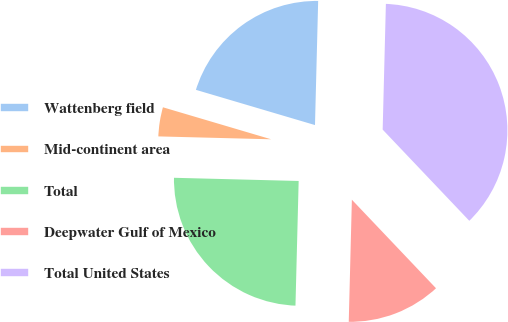Convert chart. <chart><loc_0><loc_0><loc_500><loc_500><pie_chart><fcel>Wattenberg field<fcel>Mid-continent area<fcel>Total<fcel>Deepwater Gulf of Mexico<fcel>Total United States<nl><fcel>20.83%<fcel>4.17%<fcel>25.0%<fcel>12.5%<fcel>37.5%<nl></chart> 